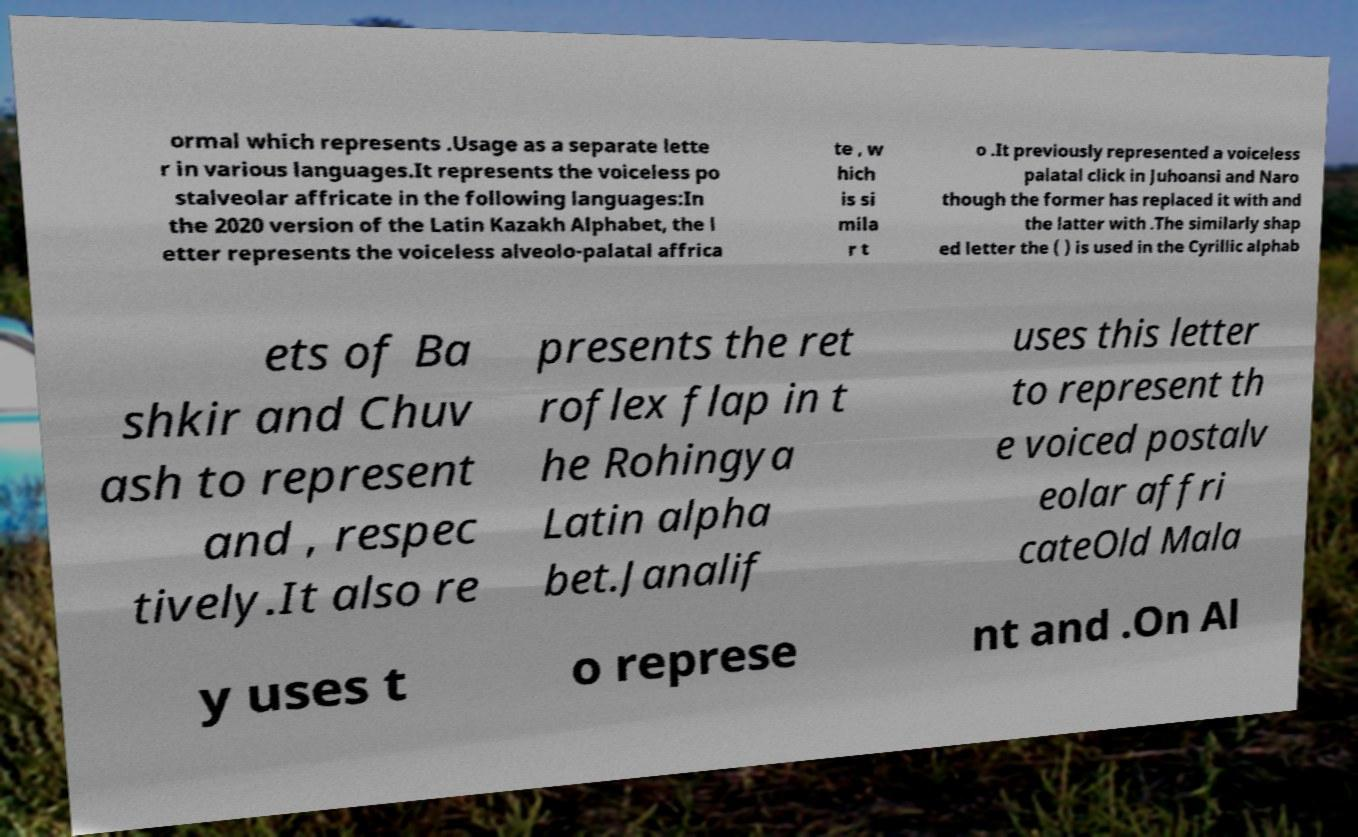Could you extract and type out the text from this image? ormal which represents .Usage as a separate lette r in various languages.It represents the voiceless po stalveolar affricate in the following languages:In the 2020 version of the Latin Kazakh Alphabet, the l etter represents the voiceless alveolo-palatal affrica te , w hich is si mila r t o .It previously represented a voiceless palatal click in Juhoansi and Naro though the former has replaced it with and the latter with .The similarly shap ed letter the ( ) is used in the Cyrillic alphab ets of Ba shkir and Chuv ash to represent and , respec tively.It also re presents the ret roflex flap in t he Rohingya Latin alpha bet.Janalif uses this letter to represent th e voiced postalv eolar affri cateOld Mala y uses t o represe nt and .On Al 